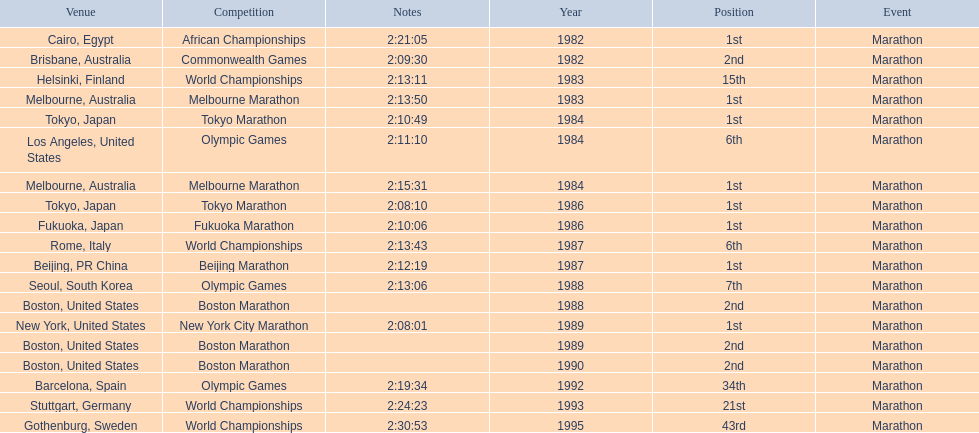Write the full table. {'header': ['Venue', 'Competition', 'Notes', 'Year', 'Position', 'Event'], 'rows': [['Cairo, Egypt', 'African Championships', '2:21:05', '1982', '1st', 'Marathon'], ['Brisbane, Australia', 'Commonwealth Games', '2:09:30', '1982', '2nd', 'Marathon'], ['Helsinki, Finland', 'World Championships', '2:13:11', '1983', '15th', 'Marathon'], ['Melbourne, Australia', 'Melbourne Marathon', '2:13:50', '1983', '1st', 'Marathon'], ['Tokyo, Japan', 'Tokyo Marathon', '2:10:49', '1984', '1st', 'Marathon'], ['Los Angeles, United States', 'Olympic Games', '2:11:10', '1984', '6th', 'Marathon'], ['Melbourne, Australia', 'Melbourne Marathon', '2:15:31', '1984', '1st', 'Marathon'], ['Tokyo, Japan', 'Tokyo Marathon', '2:08:10', '1986', '1st', 'Marathon'], ['Fukuoka, Japan', 'Fukuoka Marathon', '2:10:06', '1986', '1st', 'Marathon'], ['Rome, Italy', 'World Championships', '2:13:43', '1987', '6th', 'Marathon'], ['Beijing, PR China', 'Beijing Marathon', '2:12:19', '1987', '1st', 'Marathon'], ['Seoul, South Korea', 'Olympic Games', '2:13:06', '1988', '7th', 'Marathon'], ['Boston, United States', 'Boston Marathon', '', '1988', '2nd', 'Marathon'], ['New York, United States', 'New York City Marathon', '2:08:01', '1989', '1st', 'Marathon'], ['Boston, United States', 'Boston Marathon', '', '1989', '2nd', 'Marathon'], ['Boston, United States', 'Boston Marathon', '', '1990', '2nd', 'Marathon'], ['Barcelona, Spain', 'Olympic Games', '2:19:34', '1992', '34th', 'Marathon'], ['Stuttgart, Germany', 'World Championships', '2:24:23', '1993', '21st', 'Marathon'], ['Gothenburg, Sweden', 'World Championships', '2:30:53', '1995', '43rd', 'Marathon']]} Which competition is listed the most in this chart? World Championships. 